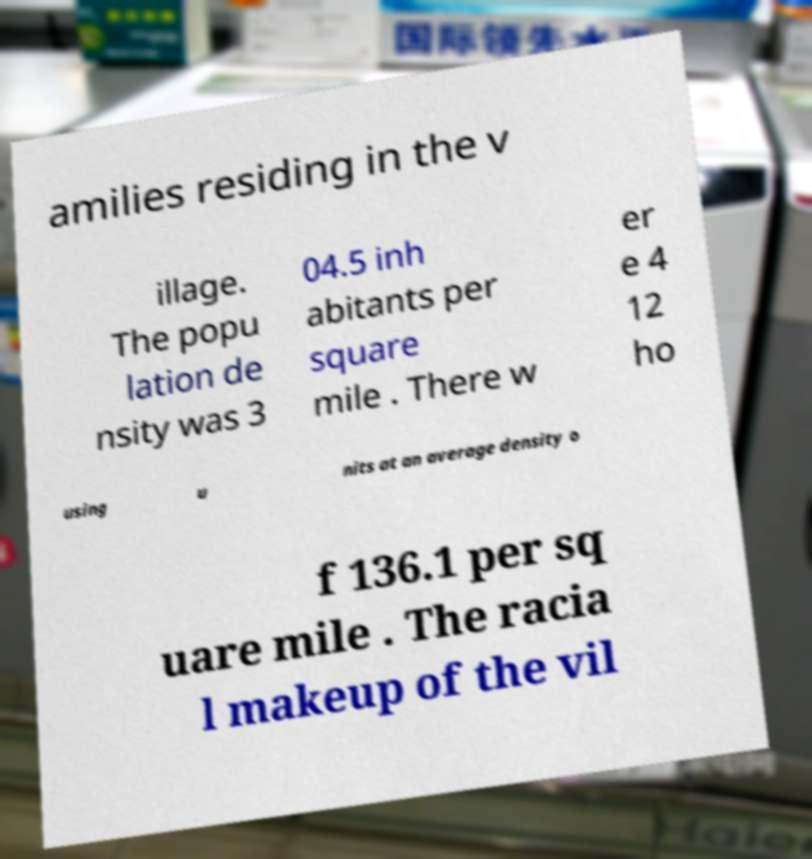I need the written content from this picture converted into text. Can you do that? amilies residing in the v illage. The popu lation de nsity was 3 04.5 inh abitants per square mile . There w er e 4 12 ho using u nits at an average density o f 136.1 per sq uare mile . The racia l makeup of the vil 